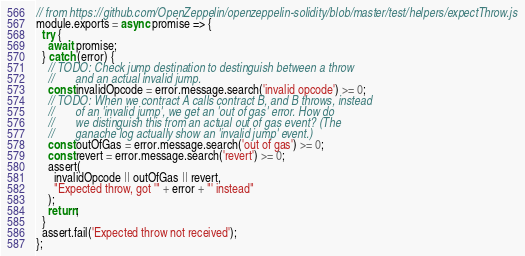Convert code to text. <code><loc_0><loc_0><loc_500><loc_500><_JavaScript_>// from https://github.com/OpenZeppelin/openzeppelin-solidity/blob/master/test/helpers/expectThrow.js
module.exports = async promise => {
  try {
    await promise;
  } catch (error) {
    // TODO: Check jump destination to destinguish between a throw
    //       and an actual invalid jump.
    const invalidOpcode = error.message.search('invalid opcode') >= 0;
    // TODO: When we contract A calls contract B, and B throws, instead
    //       of an 'invalid jump', we get an 'out of gas' error. How do
    //       we distinguish this from an actual out of gas event? (The
    //       ganache log actually show an 'invalid jump' event.)
    const outOfGas = error.message.search('out of gas') >= 0;
    const revert = error.message.search('revert') >= 0;
    assert(
      invalidOpcode || outOfGas || revert,
      "Expected throw, got '" + error + "' instead"
    );
    return;
  }
  assert.fail('Expected throw not received');
};
</code> 